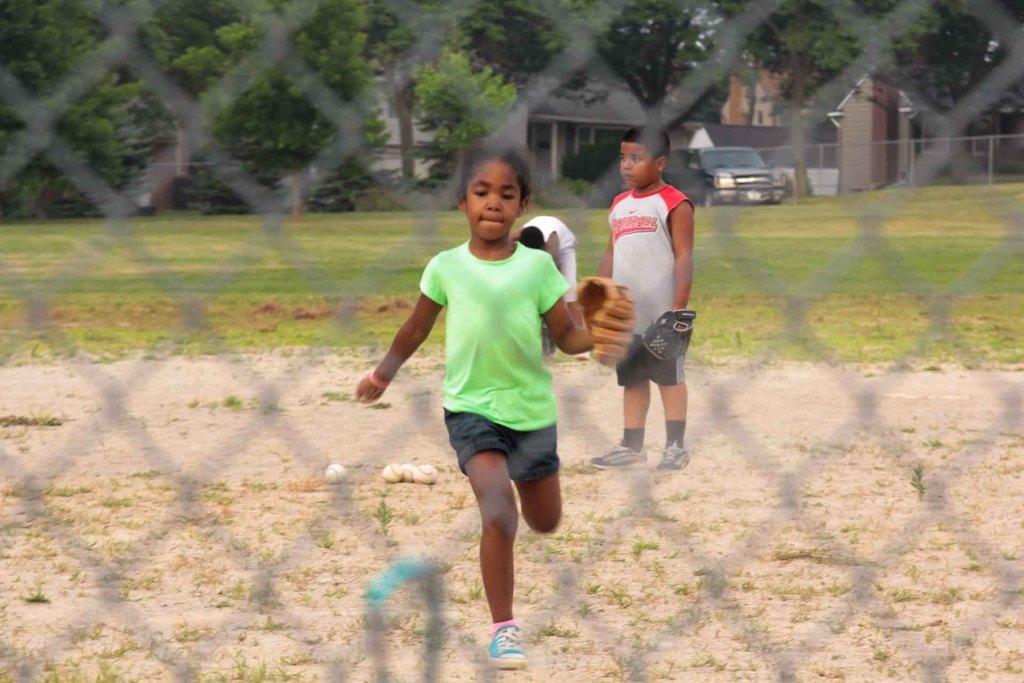Describe this image in one or two sentences. In this picture there is a girl running and there are two people standing. At the back there are buildings and trees and there is a vehicle. In the foreground there is a fence. At the bottom there are balls on the ground and there is grass. 